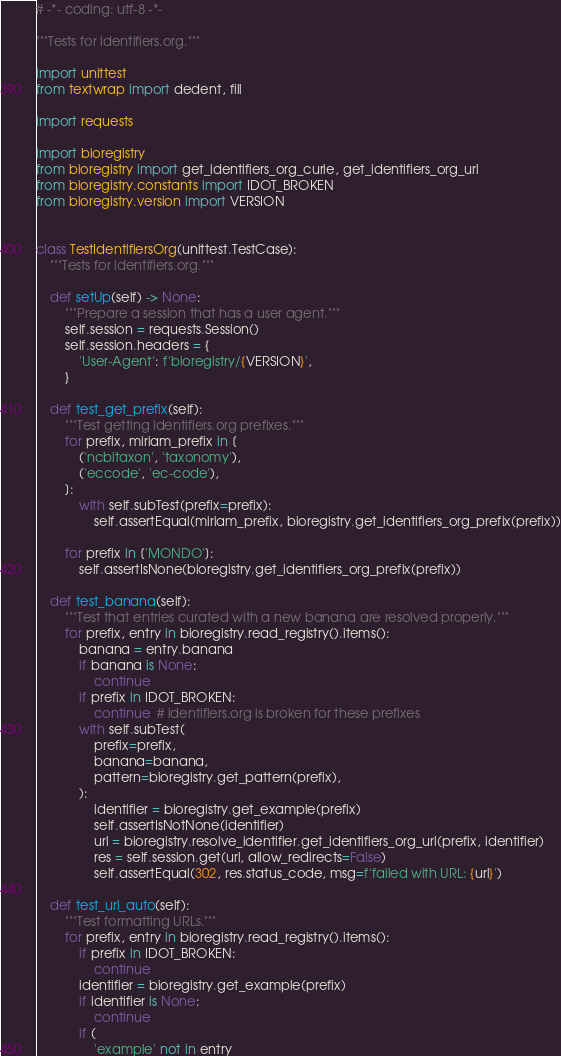<code> <loc_0><loc_0><loc_500><loc_500><_Python_># -*- coding: utf-8 -*-

"""Tests for identifiers.org."""

import unittest
from textwrap import dedent, fill

import requests

import bioregistry
from bioregistry import get_identifiers_org_curie, get_identifiers_org_url
from bioregistry.constants import IDOT_BROKEN
from bioregistry.version import VERSION


class TestIdentifiersOrg(unittest.TestCase):
    """Tests for identifiers.org."""

    def setUp(self) -> None:
        """Prepare a session that has a user agent."""
        self.session = requests.Session()
        self.session.headers = {
            'User-Agent': f'bioregistry/{VERSION}',
        }

    def test_get_prefix(self):
        """Test getting identifiers.org prefixes."""
        for prefix, miriam_prefix in [
            ('ncbitaxon', 'taxonomy'),
            ('eccode', 'ec-code'),
        ]:
            with self.subTest(prefix=prefix):
                self.assertEqual(miriam_prefix, bioregistry.get_identifiers_org_prefix(prefix))

        for prefix in ['MONDO']:
            self.assertIsNone(bioregistry.get_identifiers_org_prefix(prefix))

    def test_banana(self):
        """Test that entries curated with a new banana are resolved properly."""
        for prefix, entry in bioregistry.read_registry().items():
            banana = entry.banana
            if banana is None:
                continue
            if prefix in IDOT_BROKEN:
                continue  # identifiers.org is broken for these prefixes
            with self.subTest(
                prefix=prefix,
                banana=banana,
                pattern=bioregistry.get_pattern(prefix),
            ):
                identifier = bioregistry.get_example(prefix)
                self.assertIsNotNone(identifier)
                url = bioregistry.resolve_identifier.get_identifiers_org_url(prefix, identifier)
                res = self.session.get(url, allow_redirects=False)
                self.assertEqual(302, res.status_code, msg=f'failed with URL: {url}')

    def test_url_auto(self):
        """Test formatting URLs."""
        for prefix, entry in bioregistry.read_registry().items():
            if prefix in IDOT_BROKEN:
                continue
            identifier = bioregistry.get_example(prefix)
            if identifier is None:
                continue
            if (
                'example' not in entry</code> 